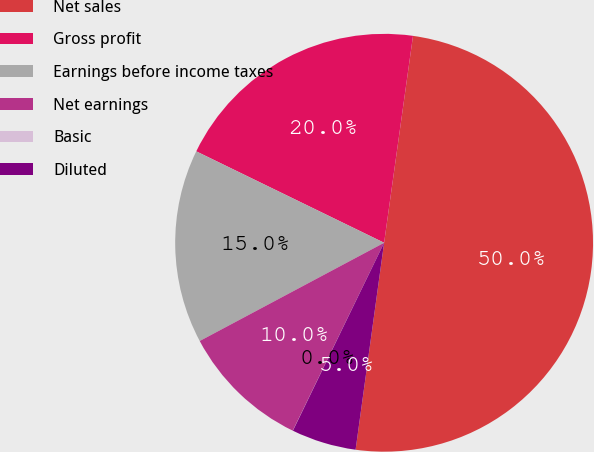Convert chart. <chart><loc_0><loc_0><loc_500><loc_500><pie_chart><fcel>Net sales<fcel>Gross profit<fcel>Earnings before income taxes<fcel>Net earnings<fcel>Basic<fcel>Diluted<nl><fcel>49.97%<fcel>20.0%<fcel>15.0%<fcel>10.01%<fcel>0.01%<fcel>5.01%<nl></chart> 